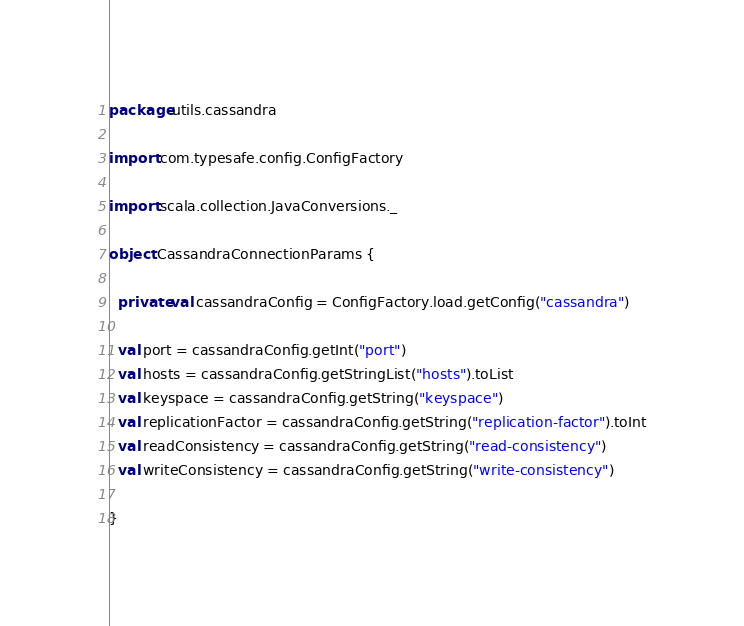Convert code to text. <code><loc_0><loc_0><loc_500><loc_500><_Scala_>package utils.cassandra

import com.typesafe.config.ConfigFactory

import scala.collection.JavaConversions._

object CassandraConnectionParams {

  private val cassandraConfig = ConfigFactory.load.getConfig("cassandra")

  val port = cassandraConfig.getInt("port")
  val hosts = cassandraConfig.getStringList("hosts").toList
  val keyspace = cassandraConfig.getString("keyspace")
  val replicationFactor = cassandraConfig.getString("replication-factor").toInt
  val readConsistency = cassandraConfig.getString("read-consistency")
  val writeConsistency = cassandraConfig.getString("write-consistency")

}
</code> 